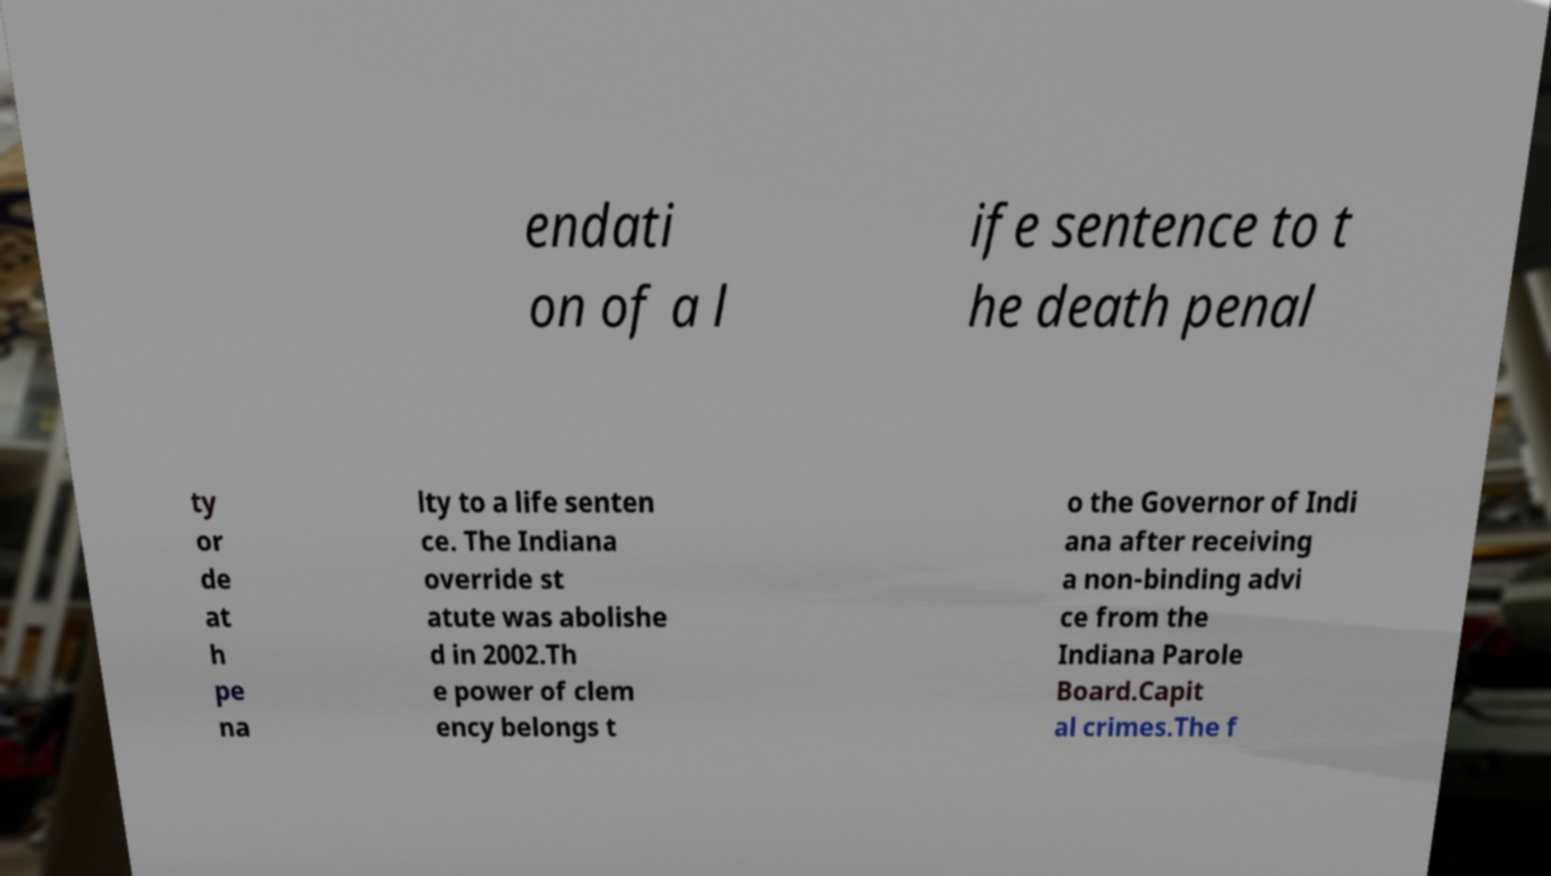Could you assist in decoding the text presented in this image and type it out clearly? endati on of a l ife sentence to t he death penal ty or de at h pe na lty to a life senten ce. The Indiana override st atute was abolishe d in 2002.Th e power of clem ency belongs t o the Governor of Indi ana after receiving a non-binding advi ce from the Indiana Parole Board.Capit al crimes.The f 